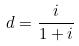<formula> <loc_0><loc_0><loc_500><loc_500>d = \frac { i } { 1 + i }</formula> 